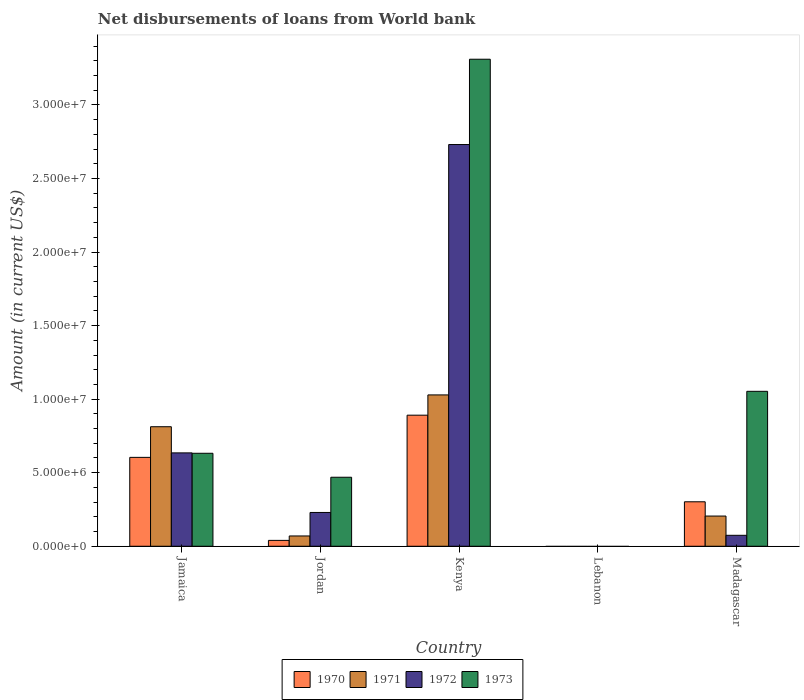Are the number of bars per tick equal to the number of legend labels?
Give a very brief answer. No. Are the number of bars on each tick of the X-axis equal?
Your answer should be very brief. No. What is the label of the 1st group of bars from the left?
Offer a very short reply. Jamaica. What is the amount of loan disbursed from World Bank in 1972 in Madagascar?
Offer a very short reply. 7.44e+05. Across all countries, what is the maximum amount of loan disbursed from World Bank in 1973?
Make the answer very short. 3.31e+07. Across all countries, what is the minimum amount of loan disbursed from World Bank in 1971?
Your answer should be compact. 0. In which country was the amount of loan disbursed from World Bank in 1972 maximum?
Offer a terse response. Kenya. What is the total amount of loan disbursed from World Bank in 1972 in the graph?
Your answer should be very brief. 3.67e+07. What is the difference between the amount of loan disbursed from World Bank in 1970 in Jamaica and that in Madagascar?
Your response must be concise. 3.02e+06. What is the difference between the amount of loan disbursed from World Bank in 1971 in Jamaica and the amount of loan disbursed from World Bank in 1970 in Madagascar?
Provide a succinct answer. 5.10e+06. What is the average amount of loan disbursed from World Bank in 1973 per country?
Offer a terse response. 1.09e+07. What is the difference between the amount of loan disbursed from World Bank of/in 1973 and amount of loan disbursed from World Bank of/in 1971 in Kenya?
Make the answer very short. 2.28e+07. What is the ratio of the amount of loan disbursed from World Bank in 1973 in Kenya to that in Madagascar?
Your answer should be compact. 3.14. Is the amount of loan disbursed from World Bank in 1972 in Jamaica less than that in Kenya?
Give a very brief answer. Yes. Is the difference between the amount of loan disbursed from World Bank in 1973 in Jordan and Kenya greater than the difference between the amount of loan disbursed from World Bank in 1971 in Jordan and Kenya?
Ensure brevity in your answer.  No. What is the difference between the highest and the second highest amount of loan disbursed from World Bank in 1972?
Make the answer very short. 2.50e+07. What is the difference between the highest and the lowest amount of loan disbursed from World Bank in 1973?
Your response must be concise. 3.31e+07. Is the sum of the amount of loan disbursed from World Bank in 1970 in Jamaica and Kenya greater than the maximum amount of loan disbursed from World Bank in 1971 across all countries?
Offer a terse response. Yes. Is it the case that in every country, the sum of the amount of loan disbursed from World Bank in 1971 and amount of loan disbursed from World Bank in 1970 is greater than the amount of loan disbursed from World Bank in 1973?
Ensure brevity in your answer.  No. How many bars are there?
Give a very brief answer. 16. Are all the bars in the graph horizontal?
Your response must be concise. No. What is the difference between two consecutive major ticks on the Y-axis?
Offer a terse response. 5.00e+06. Are the values on the major ticks of Y-axis written in scientific E-notation?
Offer a terse response. Yes. Does the graph contain grids?
Keep it short and to the point. No. How many legend labels are there?
Provide a short and direct response. 4. How are the legend labels stacked?
Your answer should be very brief. Horizontal. What is the title of the graph?
Provide a short and direct response. Net disbursements of loans from World bank. What is the label or title of the X-axis?
Your response must be concise. Country. What is the label or title of the Y-axis?
Provide a short and direct response. Amount (in current US$). What is the Amount (in current US$) of 1970 in Jamaica?
Give a very brief answer. 6.04e+06. What is the Amount (in current US$) in 1971 in Jamaica?
Make the answer very short. 8.12e+06. What is the Amount (in current US$) in 1972 in Jamaica?
Your answer should be compact. 6.35e+06. What is the Amount (in current US$) of 1973 in Jamaica?
Offer a very short reply. 6.32e+06. What is the Amount (in current US$) in 1970 in Jordan?
Give a very brief answer. 3.99e+05. What is the Amount (in current US$) in 1971 in Jordan?
Make the answer very short. 6.99e+05. What is the Amount (in current US$) of 1972 in Jordan?
Your answer should be compact. 2.30e+06. What is the Amount (in current US$) of 1973 in Jordan?
Provide a short and direct response. 4.69e+06. What is the Amount (in current US$) of 1970 in Kenya?
Offer a terse response. 8.91e+06. What is the Amount (in current US$) of 1971 in Kenya?
Keep it short and to the point. 1.03e+07. What is the Amount (in current US$) in 1972 in Kenya?
Your answer should be compact. 2.73e+07. What is the Amount (in current US$) in 1973 in Kenya?
Ensure brevity in your answer.  3.31e+07. What is the Amount (in current US$) of 1971 in Lebanon?
Offer a terse response. 0. What is the Amount (in current US$) of 1973 in Lebanon?
Make the answer very short. 0. What is the Amount (in current US$) of 1970 in Madagascar?
Provide a short and direct response. 3.02e+06. What is the Amount (in current US$) of 1971 in Madagascar?
Provide a short and direct response. 2.05e+06. What is the Amount (in current US$) in 1972 in Madagascar?
Make the answer very short. 7.44e+05. What is the Amount (in current US$) in 1973 in Madagascar?
Keep it short and to the point. 1.05e+07. Across all countries, what is the maximum Amount (in current US$) of 1970?
Your answer should be compact. 8.91e+06. Across all countries, what is the maximum Amount (in current US$) in 1971?
Your answer should be compact. 1.03e+07. Across all countries, what is the maximum Amount (in current US$) in 1972?
Offer a very short reply. 2.73e+07. Across all countries, what is the maximum Amount (in current US$) in 1973?
Give a very brief answer. 3.31e+07. What is the total Amount (in current US$) of 1970 in the graph?
Provide a succinct answer. 1.84e+07. What is the total Amount (in current US$) in 1971 in the graph?
Make the answer very short. 2.12e+07. What is the total Amount (in current US$) of 1972 in the graph?
Ensure brevity in your answer.  3.67e+07. What is the total Amount (in current US$) in 1973 in the graph?
Your answer should be compact. 5.47e+07. What is the difference between the Amount (in current US$) in 1970 in Jamaica and that in Jordan?
Keep it short and to the point. 5.64e+06. What is the difference between the Amount (in current US$) of 1971 in Jamaica and that in Jordan?
Your answer should be compact. 7.43e+06. What is the difference between the Amount (in current US$) in 1972 in Jamaica and that in Jordan?
Give a very brief answer. 4.05e+06. What is the difference between the Amount (in current US$) in 1973 in Jamaica and that in Jordan?
Your answer should be very brief. 1.63e+06. What is the difference between the Amount (in current US$) of 1970 in Jamaica and that in Kenya?
Make the answer very short. -2.87e+06. What is the difference between the Amount (in current US$) of 1971 in Jamaica and that in Kenya?
Provide a short and direct response. -2.16e+06. What is the difference between the Amount (in current US$) in 1972 in Jamaica and that in Kenya?
Give a very brief answer. -2.10e+07. What is the difference between the Amount (in current US$) of 1973 in Jamaica and that in Kenya?
Your response must be concise. -2.68e+07. What is the difference between the Amount (in current US$) of 1970 in Jamaica and that in Madagascar?
Make the answer very short. 3.02e+06. What is the difference between the Amount (in current US$) in 1971 in Jamaica and that in Madagascar?
Keep it short and to the point. 6.07e+06. What is the difference between the Amount (in current US$) in 1972 in Jamaica and that in Madagascar?
Ensure brevity in your answer.  5.60e+06. What is the difference between the Amount (in current US$) in 1973 in Jamaica and that in Madagascar?
Keep it short and to the point. -4.21e+06. What is the difference between the Amount (in current US$) of 1970 in Jordan and that in Kenya?
Offer a terse response. -8.51e+06. What is the difference between the Amount (in current US$) in 1971 in Jordan and that in Kenya?
Your response must be concise. -9.59e+06. What is the difference between the Amount (in current US$) in 1972 in Jordan and that in Kenya?
Make the answer very short. -2.50e+07. What is the difference between the Amount (in current US$) of 1973 in Jordan and that in Kenya?
Provide a succinct answer. -2.84e+07. What is the difference between the Amount (in current US$) in 1970 in Jordan and that in Madagascar?
Your answer should be very brief. -2.62e+06. What is the difference between the Amount (in current US$) in 1971 in Jordan and that in Madagascar?
Provide a short and direct response. -1.35e+06. What is the difference between the Amount (in current US$) in 1972 in Jordan and that in Madagascar?
Provide a short and direct response. 1.55e+06. What is the difference between the Amount (in current US$) in 1973 in Jordan and that in Madagascar?
Offer a terse response. -5.84e+06. What is the difference between the Amount (in current US$) in 1970 in Kenya and that in Madagascar?
Provide a short and direct response. 5.89e+06. What is the difference between the Amount (in current US$) in 1971 in Kenya and that in Madagascar?
Your response must be concise. 8.24e+06. What is the difference between the Amount (in current US$) of 1972 in Kenya and that in Madagascar?
Your response must be concise. 2.66e+07. What is the difference between the Amount (in current US$) of 1973 in Kenya and that in Madagascar?
Ensure brevity in your answer.  2.26e+07. What is the difference between the Amount (in current US$) of 1970 in Jamaica and the Amount (in current US$) of 1971 in Jordan?
Provide a succinct answer. 5.34e+06. What is the difference between the Amount (in current US$) of 1970 in Jamaica and the Amount (in current US$) of 1972 in Jordan?
Make the answer very short. 3.74e+06. What is the difference between the Amount (in current US$) in 1970 in Jamaica and the Amount (in current US$) in 1973 in Jordan?
Ensure brevity in your answer.  1.35e+06. What is the difference between the Amount (in current US$) of 1971 in Jamaica and the Amount (in current US$) of 1972 in Jordan?
Ensure brevity in your answer.  5.83e+06. What is the difference between the Amount (in current US$) in 1971 in Jamaica and the Amount (in current US$) in 1973 in Jordan?
Offer a terse response. 3.43e+06. What is the difference between the Amount (in current US$) of 1972 in Jamaica and the Amount (in current US$) of 1973 in Jordan?
Provide a short and direct response. 1.66e+06. What is the difference between the Amount (in current US$) of 1970 in Jamaica and the Amount (in current US$) of 1971 in Kenya?
Give a very brief answer. -4.25e+06. What is the difference between the Amount (in current US$) of 1970 in Jamaica and the Amount (in current US$) of 1972 in Kenya?
Give a very brief answer. -2.13e+07. What is the difference between the Amount (in current US$) of 1970 in Jamaica and the Amount (in current US$) of 1973 in Kenya?
Offer a terse response. -2.71e+07. What is the difference between the Amount (in current US$) of 1971 in Jamaica and the Amount (in current US$) of 1972 in Kenya?
Keep it short and to the point. -1.92e+07. What is the difference between the Amount (in current US$) of 1971 in Jamaica and the Amount (in current US$) of 1973 in Kenya?
Ensure brevity in your answer.  -2.50e+07. What is the difference between the Amount (in current US$) of 1972 in Jamaica and the Amount (in current US$) of 1973 in Kenya?
Provide a succinct answer. -2.68e+07. What is the difference between the Amount (in current US$) of 1970 in Jamaica and the Amount (in current US$) of 1971 in Madagascar?
Keep it short and to the point. 3.99e+06. What is the difference between the Amount (in current US$) in 1970 in Jamaica and the Amount (in current US$) in 1972 in Madagascar?
Give a very brief answer. 5.30e+06. What is the difference between the Amount (in current US$) of 1970 in Jamaica and the Amount (in current US$) of 1973 in Madagascar?
Provide a succinct answer. -4.49e+06. What is the difference between the Amount (in current US$) in 1971 in Jamaica and the Amount (in current US$) in 1972 in Madagascar?
Make the answer very short. 7.38e+06. What is the difference between the Amount (in current US$) in 1971 in Jamaica and the Amount (in current US$) in 1973 in Madagascar?
Keep it short and to the point. -2.41e+06. What is the difference between the Amount (in current US$) of 1972 in Jamaica and the Amount (in current US$) of 1973 in Madagascar?
Your answer should be very brief. -4.18e+06. What is the difference between the Amount (in current US$) of 1970 in Jordan and the Amount (in current US$) of 1971 in Kenya?
Keep it short and to the point. -9.89e+06. What is the difference between the Amount (in current US$) in 1970 in Jordan and the Amount (in current US$) in 1972 in Kenya?
Make the answer very short. -2.69e+07. What is the difference between the Amount (in current US$) of 1970 in Jordan and the Amount (in current US$) of 1973 in Kenya?
Your answer should be compact. -3.27e+07. What is the difference between the Amount (in current US$) in 1971 in Jordan and the Amount (in current US$) in 1972 in Kenya?
Provide a short and direct response. -2.66e+07. What is the difference between the Amount (in current US$) of 1971 in Jordan and the Amount (in current US$) of 1973 in Kenya?
Give a very brief answer. -3.24e+07. What is the difference between the Amount (in current US$) of 1972 in Jordan and the Amount (in current US$) of 1973 in Kenya?
Your answer should be compact. -3.08e+07. What is the difference between the Amount (in current US$) of 1970 in Jordan and the Amount (in current US$) of 1971 in Madagascar?
Offer a terse response. -1.65e+06. What is the difference between the Amount (in current US$) in 1970 in Jordan and the Amount (in current US$) in 1972 in Madagascar?
Give a very brief answer. -3.45e+05. What is the difference between the Amount (in current US$) of 1970 in Jordan and the Amount (in current US$) of 1973 in Madagascar?
Make the answer very short. -1.01e+07. What is the difference between the Amount (in current US$) in 1971 in Jordan and the Amount (in current US$) in 1972 in Madagascar?
Your answer should be very brief. -4.50e+04. What is the difference between the Amount (in current US$) of 1971 in Jordan and the Amount (in current US$) of 1973 in Madagascar?
Your response must be concise. -9.83e+06. What is the difference between the Amount (in current US$) of 1972 in Jordan and the Amount (in current US$) of 1973 in Madagascar?
Offer a very short reply. -8.24e+06. What is the difference between the Amount (in current US$) in 1970 in Kenya and the Amount (in current US$) in 1971 in Madagascar?
Provide a short and direct response. 6.86e+06. What is the difference between the Amount (in current US$) of 1970 in Kenya and the Amount (in current US$) of 1972 in Madagascar?
Give a very brief answer. 8.17e+06. What is the difference between the Amount (in current US$) of 1970 in Kenya and the Amount (in current US$) of 1973 in Madagascar?
Your answer should be very brief. -1.62e+06. What is the difference between the Amount (in current US$) of 1971 in Kenya and the Amount (in current US$) of 1972 in Madagascar?
Offer a terse response. 9.54e+06. What is the difference between the Amount (in current US$) of 1971 in Kenya and the Amount (in current US$) of 1973 in Madagascar?
Provide a succinct answer. -2.44e+05. What is the difference between the Amount (in current US$) of 1972 in Kenya and the Amount (in current US$) of 1973 in Madagascar?
Provide a short and direct response. 1.68e+07. What is the average Amount (in current US$) of 1970 per country?
Your answer should be compact. 3.67e+06. What is the average Amount (in current US$) in 1971 per country?
Ensure brevity in your answer.  4.23e+06. What is the average Amount (in current US$) in 1972 per country?
Your response must be concise. 7.34e+06. What is the average Amount (in current US$) in 1973 per country?
Your answer should be compact. 1.09e+07. What is the difference between the Amount (in current US$) in 1970 and Amount (in current US$) in 1971 in Jamaica?
Your answer should be compact. -2.08e+06. What is the difference between the Amount (in current US$) in 1970 and Amount (in current US$) in 1972 in Jamaica?
Provide a succinct answer. -3.05e+05. What is the difference between the Amount (in current US$) of 1970 and Amount (in current US$) of 1973 in Jamaica?
Provide a short and direct response. -2.79e+05. What is the difference between the Amount (in current US$) in 1971 and Amount (in current US$) in 1972 in Jamaica?
Ensure brevity in your answer.  1.78e+06. What is the difference between the Amount (in current US$) of 1971 and Amount (in current US$) of 1973 in Jamaica?
Provide a succinct answer. 1.80e+06. What is the difference between the Amount (in current US$) of 1972 and Amount (in current US$) of 1973 in Jamaica?
Offer a terse response. 2.60e+04. What is the difference between the Amount (in current US$) of 1970 and Amount (in current US$) of 1972 in Jordan?
Your answer should be very brief. -1.90e+06. What is the difference between the Amount (in current US$) of 1970 and Amount (in current US$) of 1973 in Jordan?
Offer a very short reply. -4.29e+06. What is the difference between the Amount (in current US$) of 1971 and Amount (in current US$) of 1972 in Jordan?
Give a very brief answer. -1.60e+06. What is the difference between the Amount (in current US$) in 1971 and Amount (in current US$) in 1973 in Jordan?
Give a very brief answer. -3.99e+06. What is the difference between the Amount (in current US$) of 1972 and Amount (in current US$) of 1973 in Jordan?
Make the answer very short. -2.39e+06. What is the difference between the Amount (in current US$) of 1970 and Amount (in current US$) of 1971 in Kenya?
Your answer should be very brief. -1.38e+06. What is the difference between the Amount (in current US$) of 1970 and Amount (in current US$) of 1972 in Kenya?
Offer a terse response. -1.84e+07. What is the difference between the Amount (in current US$) in 1970 and Amount (in current US$) in 1973 in Kenya?
Give a very brief answer. -2.42e+07. What is the difference between the Amount (in current US$) in 1971 and Amount (in current US$) in 1972 in Kenya?
Provide a short and direct response. -1.70e+07. What is the difference between the Amount (in current US$) of 1971 and Amount (in current US$) of 1973 in Kenya?
Your response must be concise. -2.28e+07. What is the difference between the Amount (in current US$) in 1972 and Amount (in current US$) in 1973 in Kenya?
Ensure brevity in your answer.  -5.80e+06. What is the difference between the Amount (in current US$) of 1970 and Amount (in current US$) of 1971 in Madagascar?
Offer a terse response. 9.70e+05. What is the difference between the Amount (in current US$) of 1970 and Amount (in current US$) of 1972 in Madagascar?
Your response must be concise. 2.28e+06. What is the difference between the Amount (in current US$) of 1970 and Amount (in current US$) of 1973 in Madagascar?
Make the answer very short. -7.51e+06. What is the difference between the Amount (in current US$) of 1971 and Amount (in current US$) of 1972 in Madagascar?
Provide a short and direct response. 1.31e+06. What is the difference between the Amount (in current US$) in 1971 and Amount (in current US$) in 1973 in Madagascar?
Offer a terse response. -8.48e+06. What is the difference between the Amount (in current US$) of 1972 and Amount (in current US$) of 1973 in Madagascar?
Offer a very short reply. -9.79e+06. What is the ratio of the Amount (in current US$) of 1970 in Jamaica to that in Jordan?
Provide a succinct answer. 15.14. What is the ratio of the Amount (in current US$) in 1971 in Jamaica to that in Jordan?
Give a very brief answer. 11.62. What is the ratio of the Amount (in current US$) in 1972 in Jamaica to that in Jordan?
Provide a short and direct response. 2.76. What is the ratio of the Amount (in current US$) in 1973 in Jamaica to that in Jordan?
Offer a terse response. 1.35. What is the ratio of the Amount (in current US$) in 1970 in Jamaica to that in Kenya?
Give a very brief answer. 0.68. What is the ratio of the Amount (in current US$) of 1971 in Jamaica to that in Kenya?
Your answer should be very brief. 0.79. What is the ratio of the Amount (in current US$) in 1972 in Jamaica to that in Kenya?
Your answer should be compact. 0.23. What is the ratio of the Amount (in current US$) of 1973 in Jamaica to that in Kenya?
Your answer should be compact. 0.19. What is the ratio of the Amount (in current US$) in 1970 in Jamaica to that in Madagascar?
Your answer should be compact. 2. What is the ratio of the Amount (in current US$) in 1971 in Jamaica to that in Madagascar?
Give a very brief answer. 3.96. What is the ratio of the Amount (in current US$) in 1972 in Jamaica to that in Madagascar?
Your answer should be very brief. 8.53. What is the ratio of the Amount (in current US$) of 1973 in Jamaica to that in Madagascar?
Offer a terse response. 0.6. What is the ratio of the Amount (in current US$) of 1970 in Jordan to that in Kenya?
Make the answer very short. 0.04. What is the ratio of the Amount (in current US$) in 1971 in Jordan to that in Kenya?
Offer a terse response. 0.07. What is the ratio of the Amount (in current US$) in 1972 in Jordan to that in Kenya?
Make the answer very short. 0.08. What is the ratio of the Amount (in current US$) of 1973 in Jordan to that in Kenya?
Your answer should be compact. 0.14. What is the ratio of the Amount (in current US$) in 1970 in Jordan to that in Madagascar?
Offer a very short reply. 0.13. What is the ratio of the Amount (in current US$) in 1971 in Jordan to that in Madagascar?
Keep it short and to the point. 0.34. What is the ratio of the Amount (in current US$) in 1972 in Jordan to that in Madagascar?
Ensure brevity in your answer.  3.09. What is the ratio of the Amount (in current US$) in 1973 in Jordan to that in Madagascar?
Ensure brevity in your answer.  0.45. What is the ratio of the Amount (in current US$) of 1970 in Kenya to that in Madagascar?
Offer a very short reply. 2.95. What is the ratio of the Amount (in current US$) in 1971 in Kenya to that in Madagascar?
Offer a terse response. 5.01. What is the ratio of the Amount (in current US$) of 1972 in Kenya to that in Madagascar?
Keep it short and to the point. 36.7. What is the ratio of the Amount (in current US$) of 1973 in Kenya to that in Madagascar?
Provide a succinct answer. 3.14. What is the difference between the highest and the second highest Amount (in current US$) of 1970?
Offer a very short reply. 2.87e+06. What is the difference between the highest and the second highest Amount (in current US$) in 1971?
Keep it short and to the point. 2.16e+06. What is the difference between the highest and the second highest Amount (in current US$) of 1972?
Make the answer very short. 2.10e+07. What is the difference between the highest and the second highest Amount (in current US$) in 1973?
Your answer should be very brief. 2.26e+07. What is the difference between the highest and the lowest Amount (in current US$) of 1970?
Give a very brief answer. 8.91e+06. What is the difference between the highest and the lowest Amount (in current US$) in 1971?
Ensure brevity in your answer.  1.03e+07. What is the difference between the highest and the lowest Amount (in current US$) of 1972?
Provide a short and direct response. 2.73e+07. What is the difference between the highest and the lowest Amount (in current US$) in 1973?
Offer a terse response. 3.31e+07. 